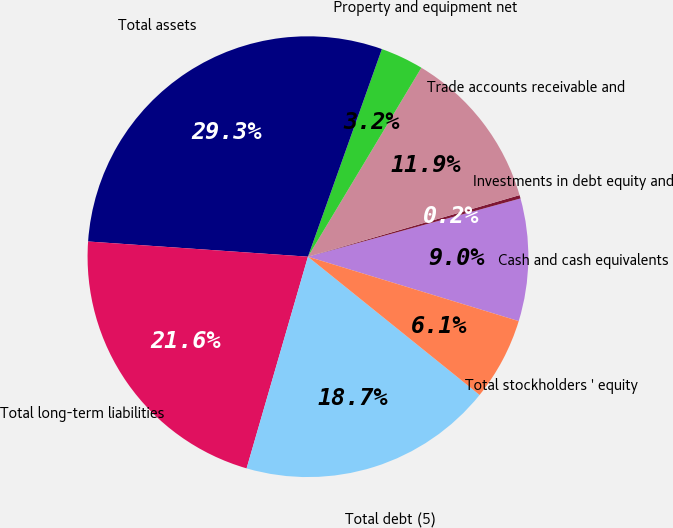<chart> <loc_0><loc_0><loc_500><loc_500><pie_chart><fcel>Cash and cash equivalents<fcel>Investments in debt equity and<fcel>Trade accounts receivable and<fcel>Property and equipment net<fcel>Total assets<fcel>Total long-term liabilities<fcel>Total debt (5)<fcel>Total stockholders ' equity<nl><fcel>8.98%<fcel>0.25%<fcel>11.89%<fcel>3.16%<fcel>29.35%<fcel>21.61%<fcel>18.7%<fcel>6.07%<nl></chart> 